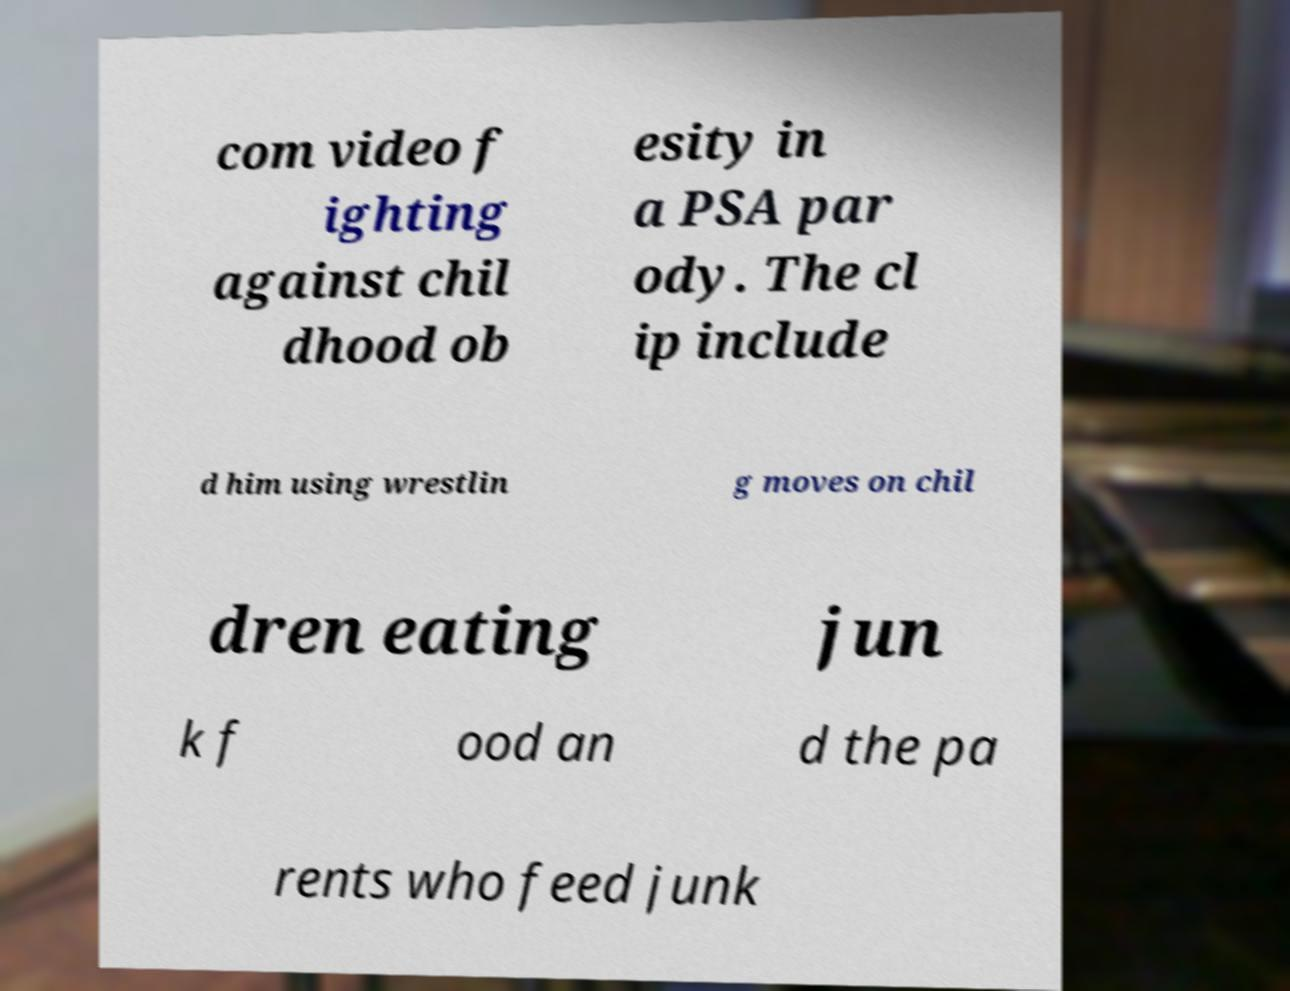For documentation purposes, I need the text within this image transcribed. Could you provide that? com video f ighting against chil dhood ob esity in a PSA par ody. The cl ip include d him using wrestlin g moves on chil dren eating jun k f ood an d the pa rents who feed junk 